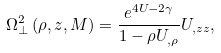<formula> <loc_0><loc_0><loc_500><loc_500>\Omega _ { \perp } ^ { 2 } \left ( \rho , z , M \right ) = \frac { e ^ { 4 U - 2 \gamma } } { 1 - \rho U _ { , \rho } } U _ { , z z } ,</formula> 